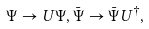Convert formula to latex. <formula><loc_0><loc_0><loc_500><loc_500>\Psi \rightarrow U \Psi , \bar { \Psi } \rightarrow \bar { \Psi } U ^ { \dagger } ,</formula> 